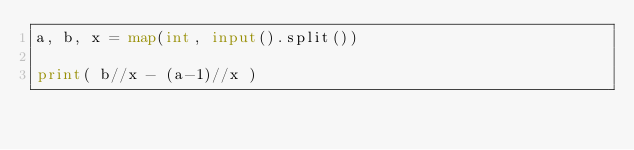<code> <loc_0><loc_0><loc_500><loc_500><_Python_>a, b, x = map(int, input().split())

print( b//x - (a-1)//x )</code> 